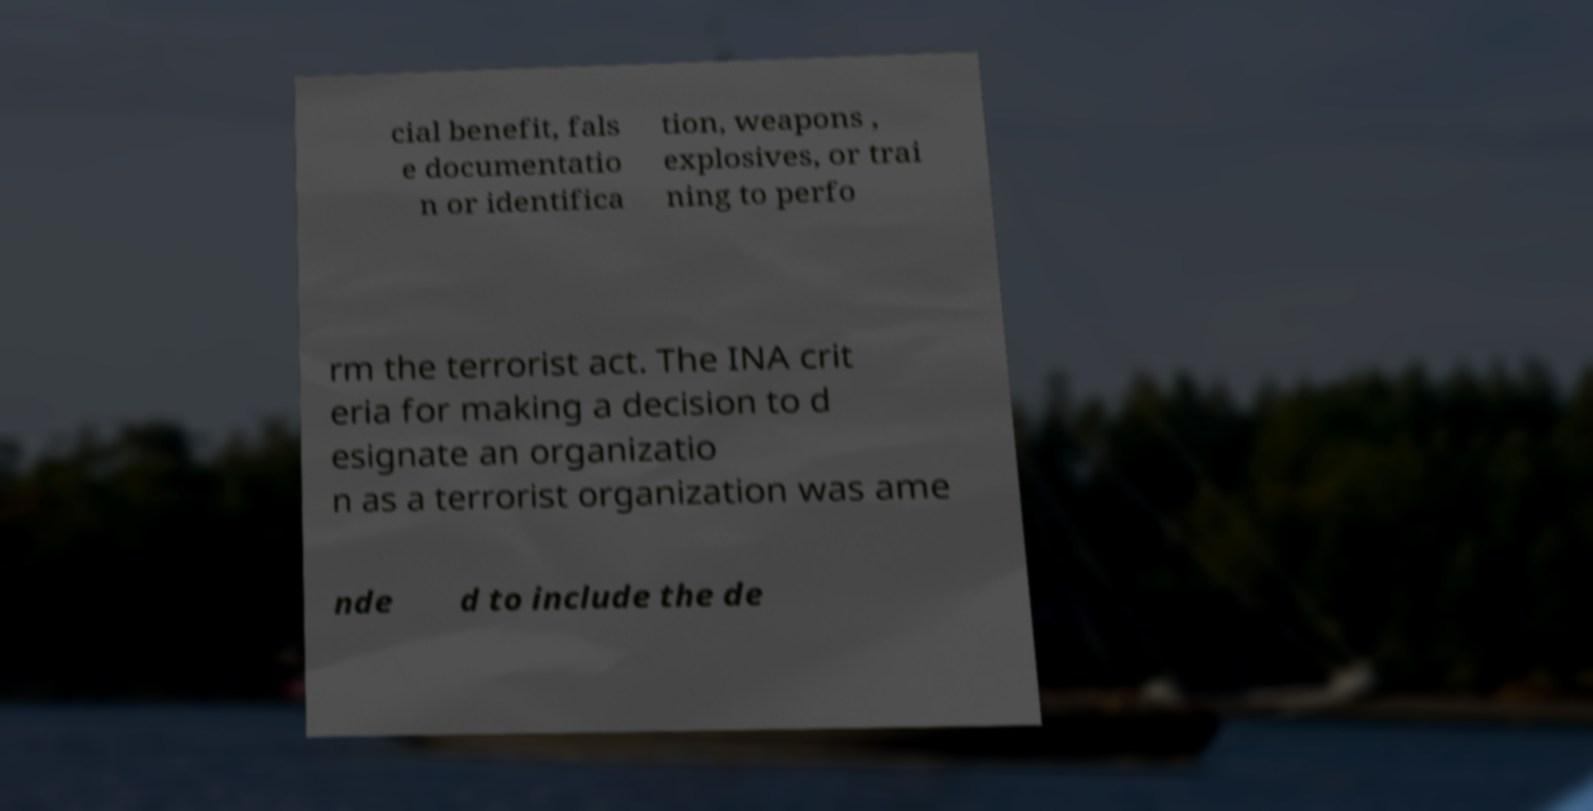There's text embedded in this image that I need extracted. Can you transcribe it verbatim? cial benefit, fals e documentatio n or identifica tion, weapons , explosives, or trai ning to perfo rm the terrorist act. The INA crit eria for making a decision to d esignate an organizatio n as a terrorist organization was ame nde d to include the de 